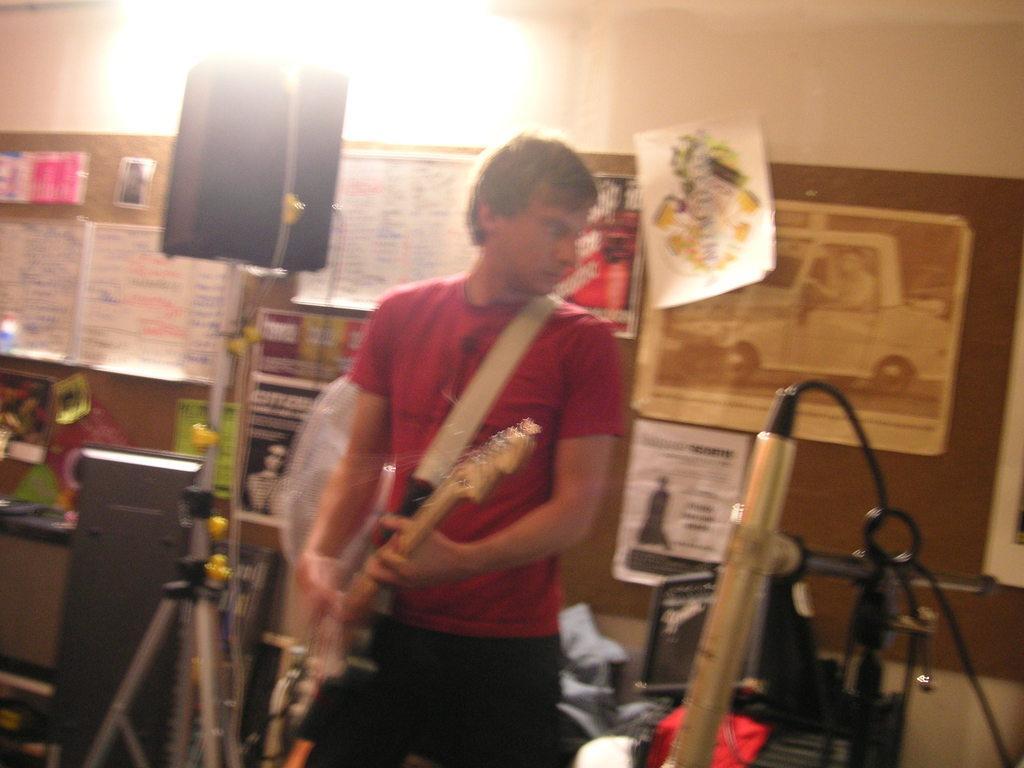Can you describe this image briefly? In this image I can see a person wearing red t shirt and black pant is standing and holding a musical instrument in his hand. In the background I can see the wall, few posts attached to the wall, a microphone, a light and few other objects. 